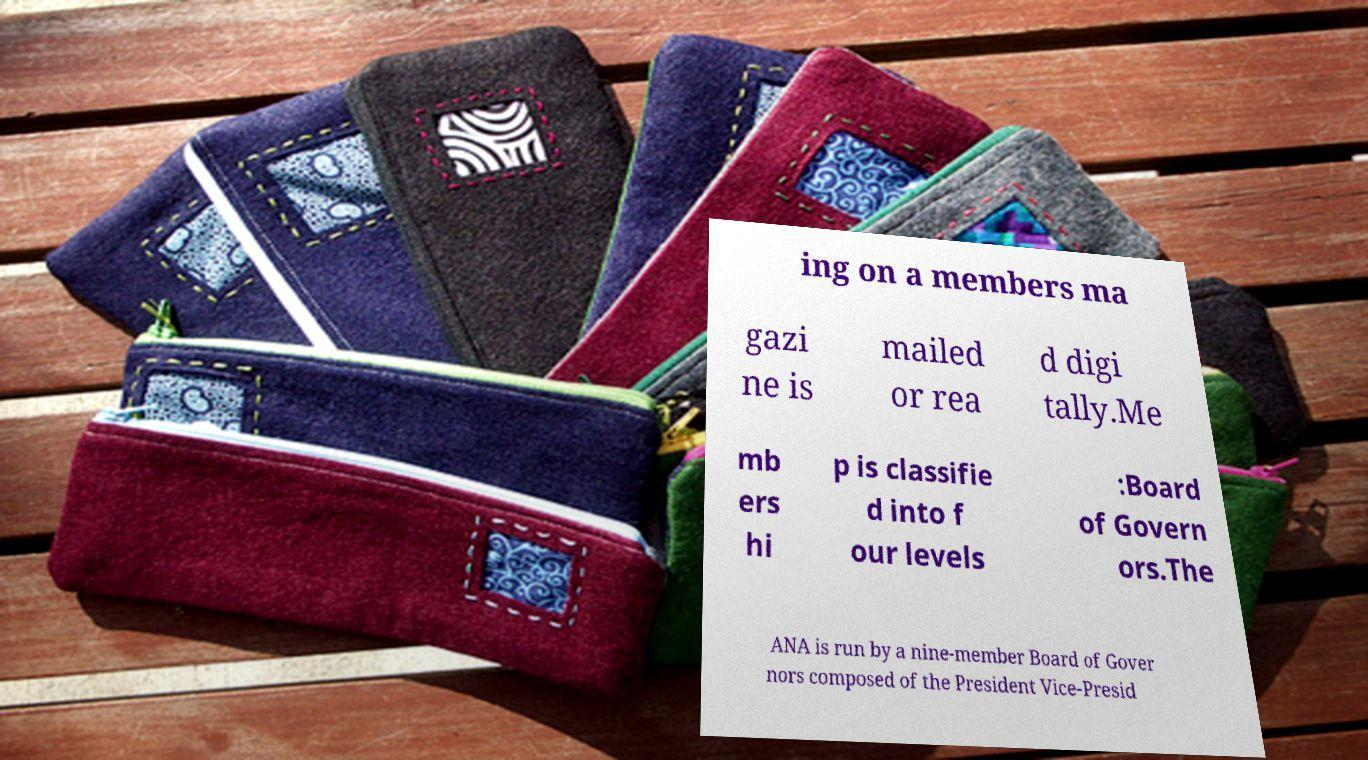What messages or text are displayed in this image? I need them in a readable, typed format. ing on a members ma gazi ne is mailed or rea d digi tally.Me mb ers hi p is classifie d into f our levels :Board of Govern ors.The ANA is run by a nine-member Board of Gover nors composed of the President Vice-Presid 